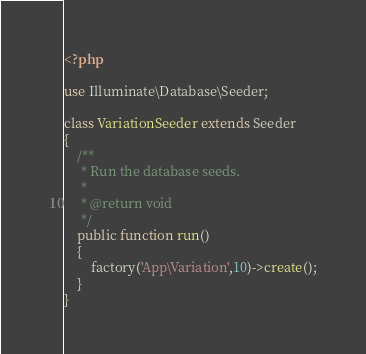<code> <loc_0><loc_0><loc_500><loc_500><_PHP_><?php

use Illuminate\Database\Seeder;

class VariationSeeder extends Seeder
{
    /**
     * Run the database seeds.
     *
     * @return void
     */
    public function run()
    {
        factory('App\Variation',10)->create();
    }
}
</code> 